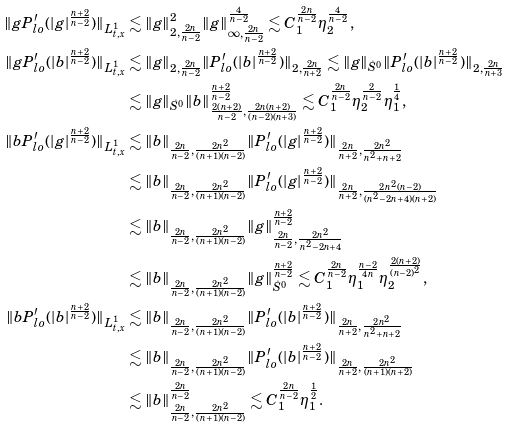<formula> <loc_0><loc_0><loc_500><loc_500>\| g P _ { l o } ^ { \prime } ( | g | ^ { \frac { n + 2 } { n - 2 } } ) \| _ { L ^ { 1 } _ { t , x } } & \lesssim \| g \| ^ { 2 } _ { 2 , \frac { 2 n } { n - 2 } } \| g \| _ { \infty , \frac { 2 n } { n - 2 } } ^ { \frac { 4 } { n - 2 } } \lesssim C _ { 1 } ^ { \frac { 2 n } { n - 2 } } \eta _ { 2 } ^ { \frac { 4 } { n - 2 } } , \\ \| g P _ { l o } ^ { \prime } ( | b | ^ { \frac { n + 2 } { n - 2 } } ) \| _ { L ^ { 1 } _ { t , x } } & \lesssim \| g \| _ { 2 , \frac { 2 n } { n - 2 } } \| P _ { l o } ^ { \prime } ( | b | ^ { \frac { n + 2 } { n - 2 } } ) \| _ { 2 , \frac { 2 n } { n + 2 } } \lesssim \| g \| _ { \dot { S } ^ { 0 } } \| P _ { l o } ^ { \prime } ( | b | ^ { \frac { n + 2 } { n - 2 } } ) \| _ { 2 , \frac { 2 n } { n + 3 } } \\ & \lesssim \| g \| _ { \dot { S } ^ { 0 } } \| b \| _ { \frac { 2 ( n + 2 ) } { n - 2 } , \frac { 2 n ( n + 2 ) } { ( n - 2 ) ( n + 3 ) } } ^ { \frac { n + 2 } { n - 2 } } \lesssim C _ { 1 } ^ { \frac { 2 n } { n - 2 } } \eta _ { 2 } ^ { \frac { 2 } { n - 2 } } \eta _ { 1 } ^ { \frac { 1 } { 4 } } , \\ \| b P _ { l o } ^ { \prime } ( | g | ^ { \frac { n + 2 } { n - 2 } } ) \| _ { L ^ { 1 } _ { t , x } } & \lesssim \| b \| _ { \frac { 2 n } { n - 2 } , \frac { 2 n ^ { 2 } } { ( n + 1 ) ( n - 2 ) } } \| P _ { l o } ^ { \prime } ( | g | ^ { \frac { n + 2 } { n - 2 } } ) \| _ { \frac { 2 n } { n + 2 } , \frac { 2 n ^ { 2 } } { n ^ { 2 } + n + 2 } } \\ & \lesssim \| b \| _ { \frac { 2 n } { n - 2 } , \frac { 2 n ^ { 2 } } { ( n + 1 ) ( n - 2 ) } } \| P _ { l o } ^ { \prime } ( | g | ^ { \frac { n + 2 } { n - 2 } } ) \| _ { \frac { 2 n } { n + 2 } , \frac { 2 n ^ { 2 } ( n - 2 ) } { ( n ^ { 2 } - 2 n + 4 ) ( n + 2 ) } } \\ & \lesssim \| b \| _ { \frac { 2 n } { n - 2 } , \frac { 2 n ^ { 2 } } { ( n + 1 ) ( n - 2 ) } } \| g \| _ { \frac { 2 n } { n - 2 } , \frac { 2 n ^ { 2 } } { n ^ { 2 } - 2 n + 4 } } ^ { \frac { n + 2 } { n - 2 } } \\ & \lesssim \| b \| _ { \frac { 2 n } { n - 2 } , \frac { 2 n ^ { 2 } } { ( n + 1 ) ( n - 2 ) } } \| g \| _ { \dot { S } ^ { 0 } } ^ { \frac { n + 2 } { n - 2 } } \lesssim C _ { 1 } ^ { \frac { 2 n } { n - 2 } } \eta _ { 1 } ^ { \frac { n - 2 } { 4 n } } \eta _ { 2 } ^ { \frac { 2 ( n + 2 ) } { ( n - 2 ) ^ { 2 } } } , \\ \| b P _ { l o } ^ { \prime } ( | b | ^ { \frac { n + 2 } { n - 2 } } ) \| _ { L ^ { 1 } _ { t , x } } & \lesssim \| b \| _ { \frac { 2 n } { n - 2 } , \frac { 2 n ^ { 2 } } { ( n + 1 ) ( n - 2 ) } } \| P _ { l o } ^ { \prime } ( | b | ^ { \frac { n + 2 } { n - 2 } } ) \| _ { \frac { 2 n } { n + 2 } , \frac { 2 n ^ { 2 } } { n ^ { 2 } + n + 2 } } \\ & \lesssim \| b \| _ { \frac { 2 n } { n - 2 } , \frac { 2 n ^ { 2 } } { ( n + 1 ) ( n - 2 ) } } \| P _ { l o } ^ { \prime } ( | b | ^ { \frac { n + 2 } { n - 2 } } ) \| _ { \frac { 2 n } { n + 2 } , \frac { 2 n ^ { 2 } } { ( n + 1 ) ( n + 2 ) } } \\ & \lesssim \| b \| _ { \frac { 2 n } { n - 2 } , \frac { 2 n ^ { 2 } } { ( n + 1 ) ( n - 2 ) } } ^ { \frac { 2 n } { n - 2 } } \lesssim C _ { 1 } ^ { \frac { 2 n } { n - 2 } } \eta _ { 1 } ^ { \frac { 1 } { 2 } } .</formula> 